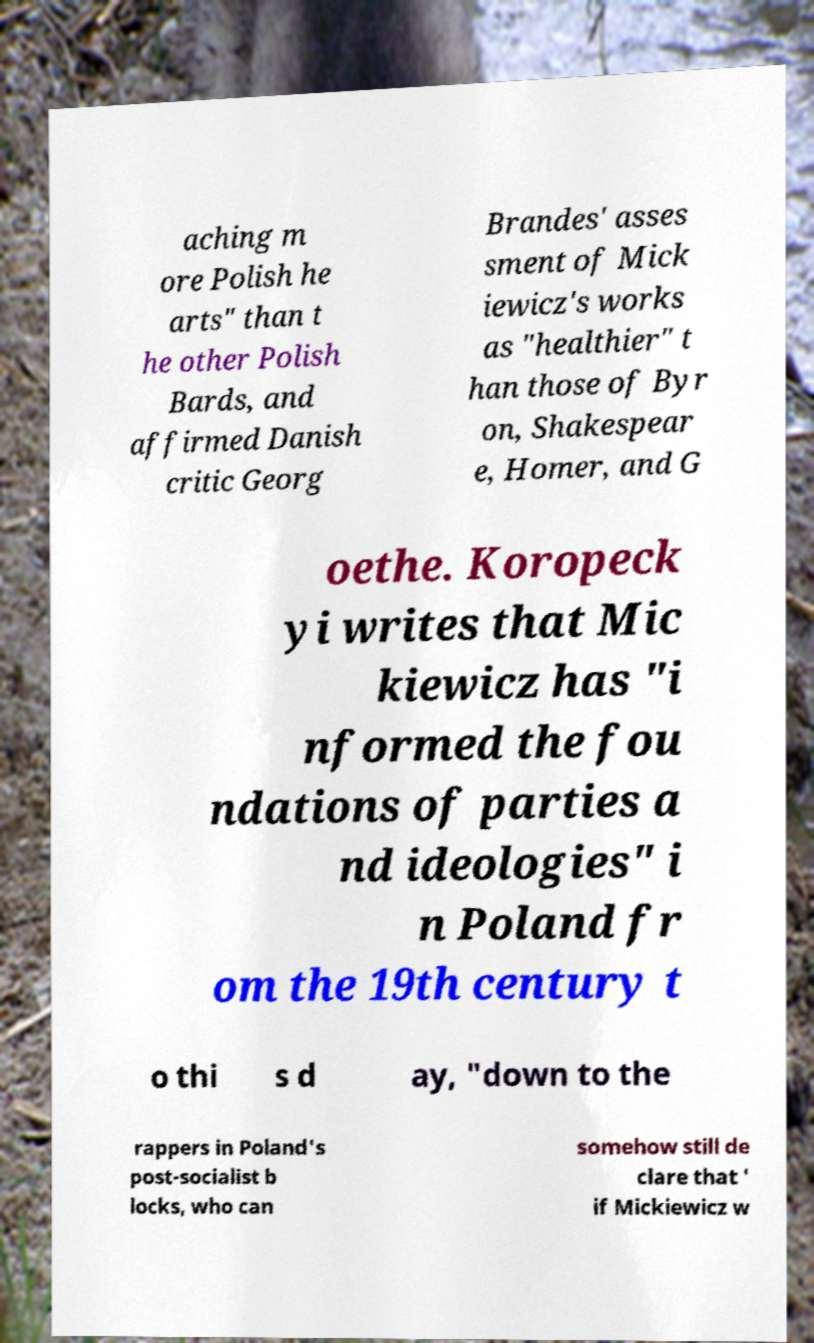Could you assist in decoding the text presented in this image and type it out clearly? aching m ore Polish he arts" than t he other Polish Bards, and affirmed Danish critic Georg Brandes' asses sment of Mick iewicz's works as "healthier" t han those of Byr on, Shakespear e, Homer, and G oethe. Koropeck yi writes that Mic kiewicz has "i nformed the fou ndations of parties a nd ideologies" i n Poland fr om the 19th century t o thi s d ay, "down to the rappers in Poland's post-socialist b locks, who can somehow still de clare that ' if Mickiewicz w 